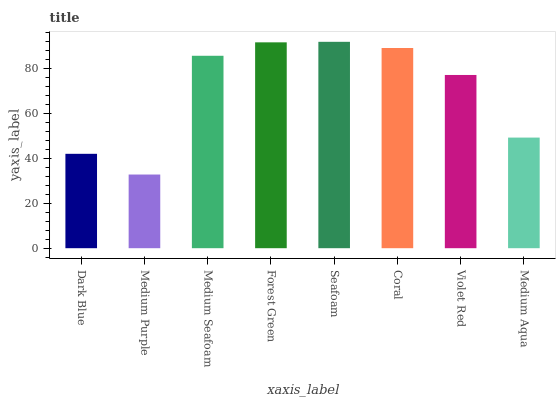Is Medium Seafoam the minimum?
Answer yes or no. No. Is Medium Seafoam the maximum?
Answer yes or no. No. Is Medium Seafoam greater than Medium Purple?
Answer yes or no. Yes. Is Medium Purple less than Medium Seafoam?
Answer yes or no. Yes. Is Medium Purple greater than Medium Seafoam?
Answer yes or no. No. Is Medium Seafoam less than Medium Purple?
Answer yes or no. No. Is Medium Seafoam the high median?
Answer yes or no. Yes. Is Violet Red the low median?
Answer yes or no. Yes. Is Dark Blue the high median?
Answer yes or no. No. Is Medium Purple the low median?
Answer yes or no. No. 